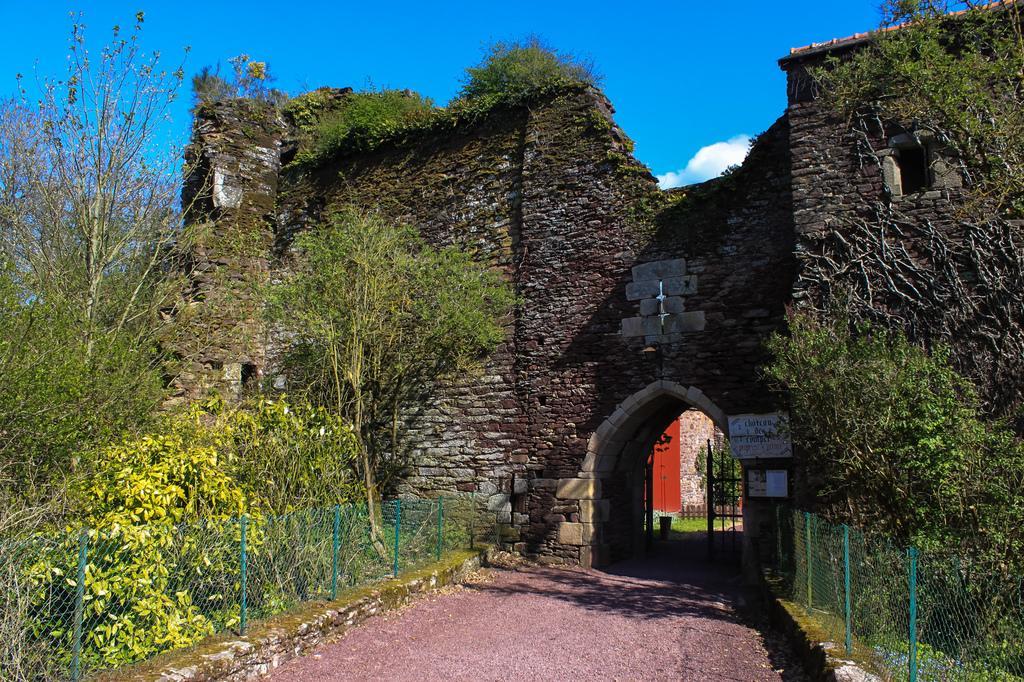In one or two sentences, can you explain what this image depicts? In this picture there is a building and there are trees and there is a fence. In the foreground there is a gate and there is a board on the wall and there is text on the board. At the top there is sky and there are clouds. At the bottom there is a pavement. 